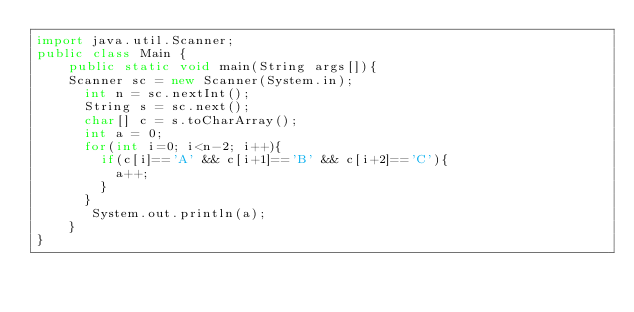Convert code to text. <code><loc_0><loc_0><loc_500><loc_500><_Java_>import java.util.Scanner;
public class Main {
	public static void main(String args[]){
	Scanner sc = new Scanner(System.in);
      int n = sc.nextInt();
      String s = sc.next();
      char[] c = s.toCharArray();
      int a = 0;
      for(int i=0; i<n-2; i++){
        if(c[i]=='A' && c[i+1]=='B' && c[i+2]=='C'){
          a++;
        }
      }
       System.out.println(a);
    }
}</code> 